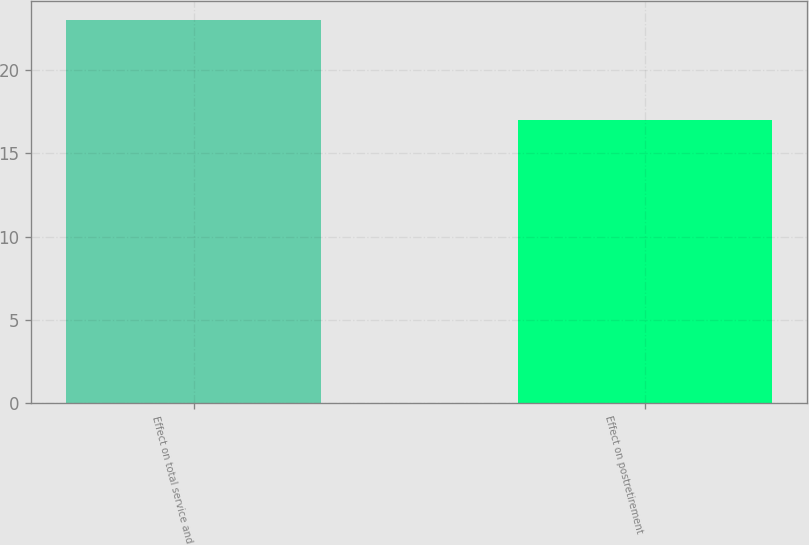Convert chart to OTSL. <chart><loc_0><loc_0><loc_500><loc_500><bar_chart><fcel>Effect on total service and<fcel>Effect on postretirement<nl><fcel>23<fcel>17<nl></chart> 